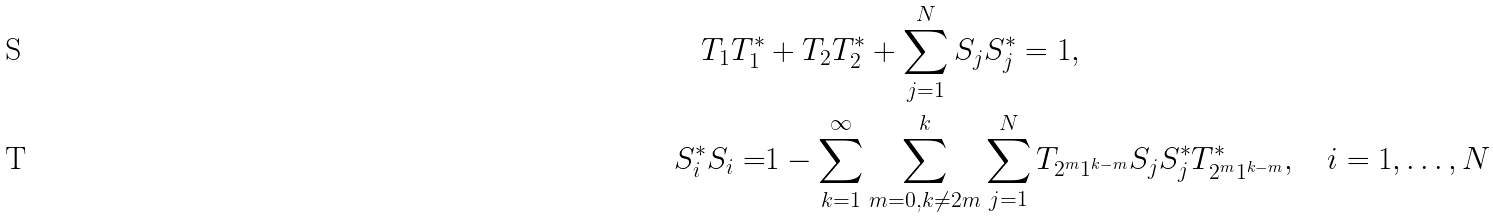Convert formula to latex. <formula><loc_0><loc_0><loc_500><loc_500>T _ { 1 } T _ { 1 } ^ { * } & + T _ { 2 } T _ { 2 } ^ { * } + \sum _ { j = 1 } ^ { N } S _ { j } S _ { j } ^ { * } = 1 , \\ S _ { i } ^ { * } S _ { i } = & 1 - \sum _ { k = 1 } ^ { \infty } \sum _ { m = 0 , k \ne 2 m } ^ { k } \sum _ { j = 1 } ^ { N } T _ { 2 ^ { m } 1 ^ { k - m } } S _ { j } S _ { j } ^ { * } T _ { 2 ^ { m } 1 ^ { k - m } } ^ { * } , \quad i = 1 , \dots , N</formula> 